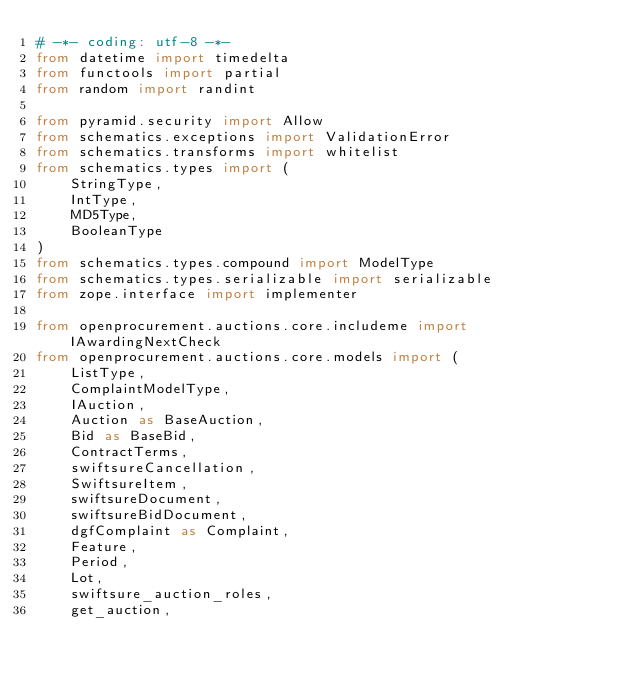<code> <loc_0><loc_0><loc_500><loc_500><_Python_># -*- coding: utf-8 -*-
from datetime import timedelta
from functools import partial
from random import randint

from pyramid.security import Allow
from schematics.exceptions import ValidationError
from schematics.transforms import whitelist
from schematics.types import (
    StringType,
    IntType,
    MD5Type,
    BooleanType
)
from schematics.types.compound import ModelType
from schematics.types.serializable import serializable
from zope.interface import implementer

from openprocurement.auctions.core.includeme import IAwardingNextCheck
from openprocurement.auctions.core.models import (
    ListType,
    ComplaintModelType,
    IAuction,
    Auction as BaseAuction,
    Bid as BaseBid,
    ContractTerms,
    swiftsureCancellation,
    SwiftsureItem,
    swiftsureDocument,
    swiftsureBidDocument,
    dgfComplaint as Complaint,
    Feature,
    Period,
    Lot,
    swiftsure_auction_roles,
    get_auction,</code> 